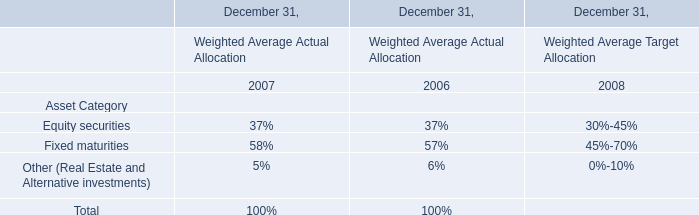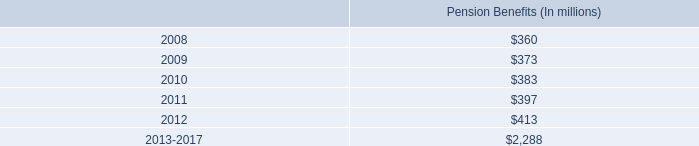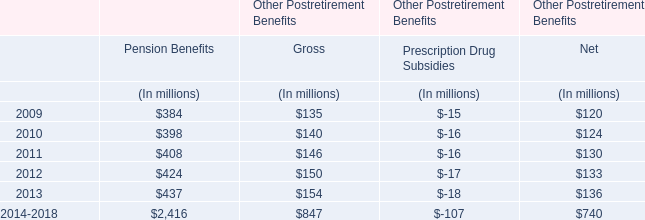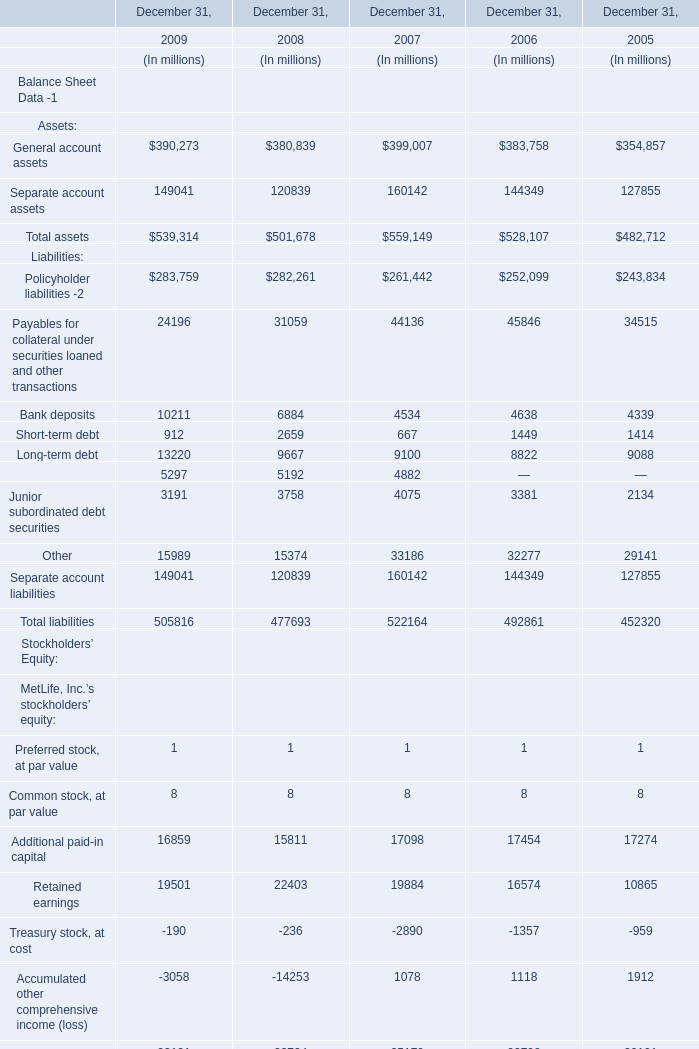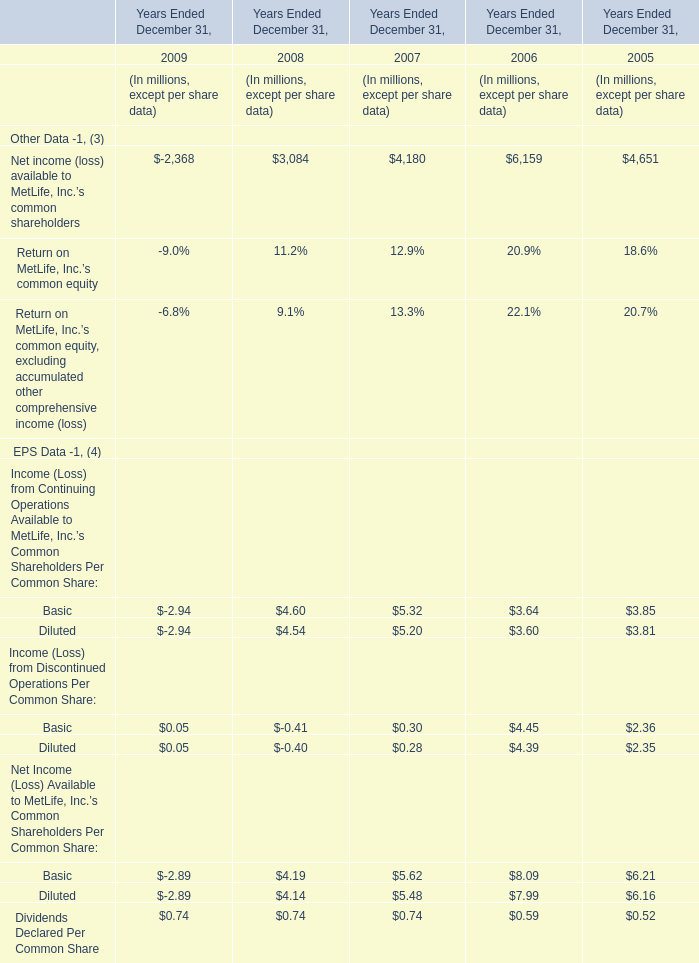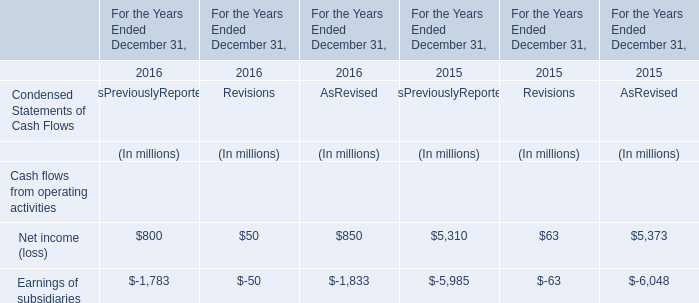When does Net income (loss) available to MetLife, Inc.'s common shareholders reach the largest value? 
Answer: 2006. 